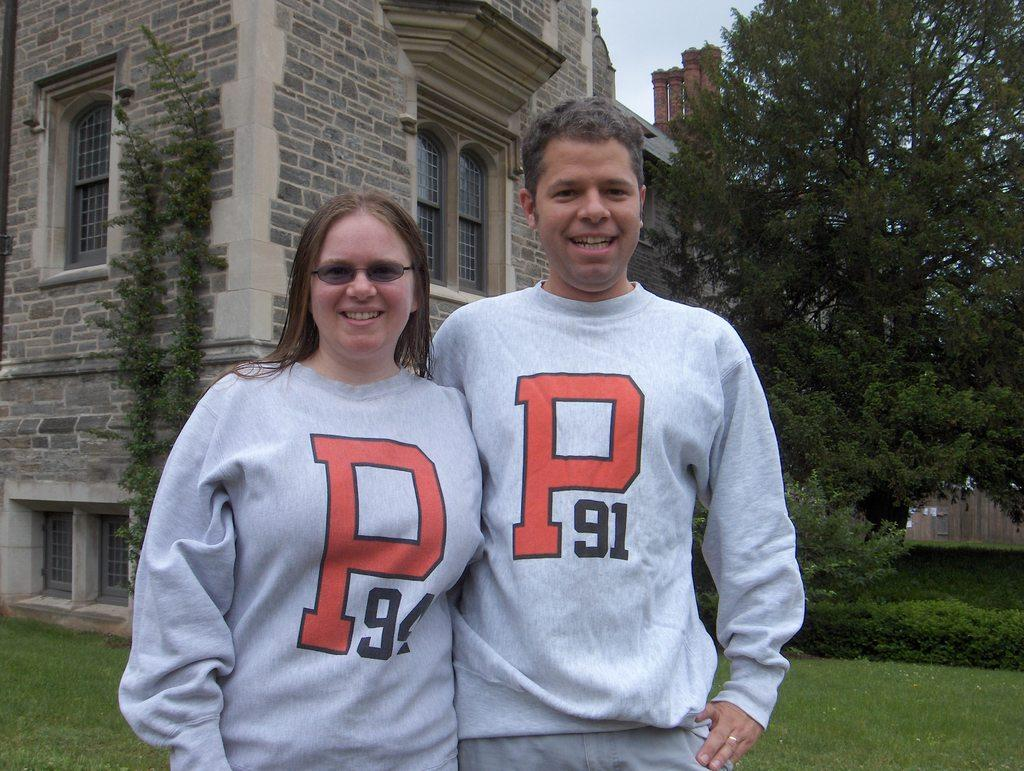Provide a one-sentence caption for the provided image. A man and a woman wearing shirts that have the letter P and a number. 